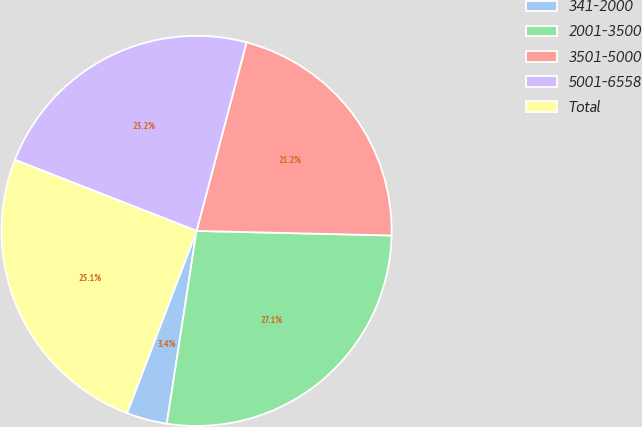Convert chart to OTSL. <chart><loc_0><loc_0><loc_500><loc_500><pie_chart><fcel>341-2000<fcel>2001-3500<fcel>3501-5000<fcel>5001-6558<fcel>Total<nl><fcel>3.36%<fcel>27.07%<fcel>21.25%<fcel>23.19%<fcel>25.13%<nl></chart> 